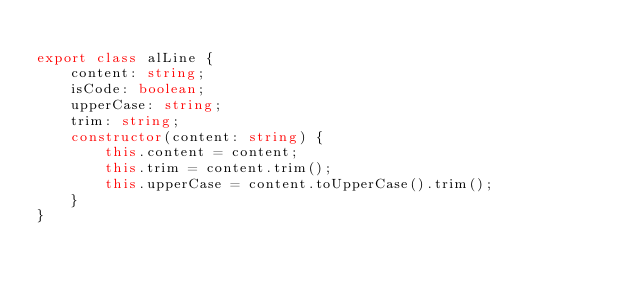<code> <loc_0><loc_0><loc_500><loc_500><_TypeScript_>
export class alLine {
    content: string;
    isCode: boolean;
    upperCase: string;
    trim: string;
    constructor(content: string) {
        this.content = content;
        this.trim = content.trim();
        this.upperCase = content.toUpperCase().trim();
    }
}
</code> 